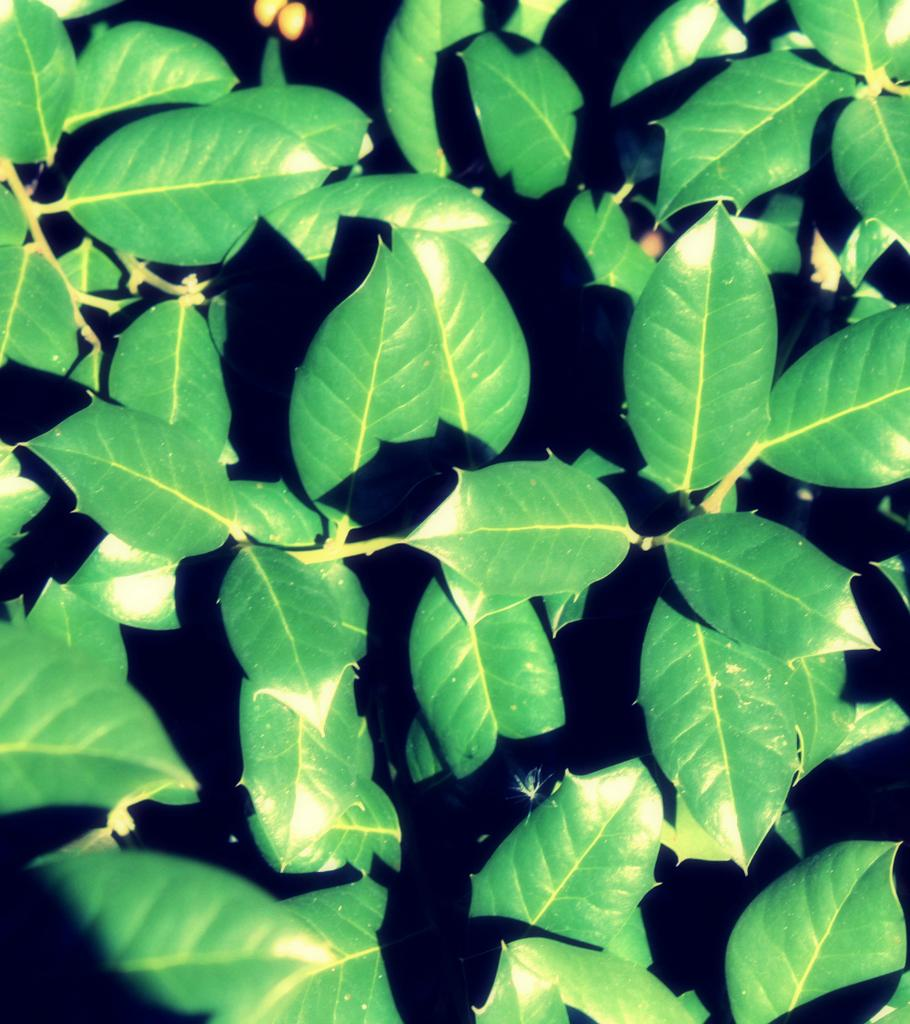What type of vegetation is present in the image? There are green leaves in the image. What type of argument is being held by the jellyfish in the image? There are no jellyfish present in the image; it only contains green leaves. 